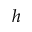Convert formula to latex. <formula><loc_0><loc_0><loc_500><loc_500>h</formula> 